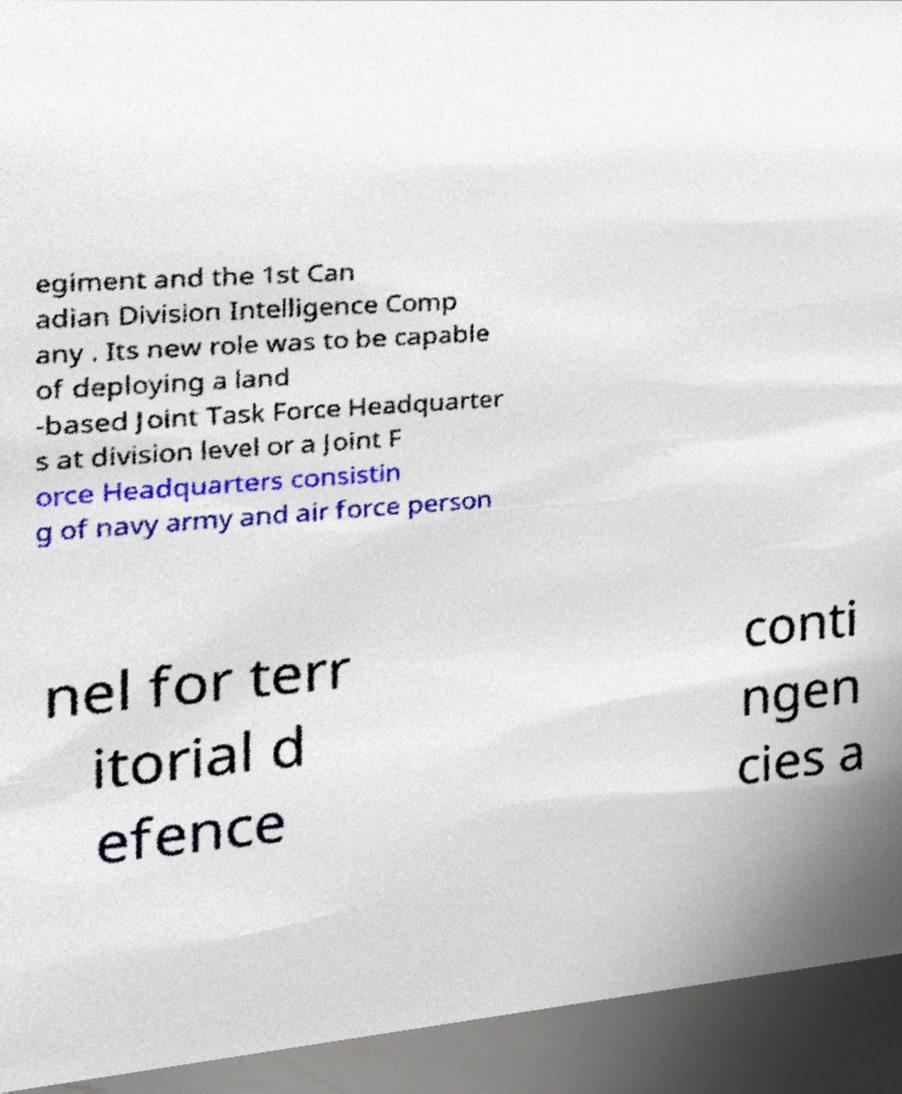I need the written content from this picture converted into text. Can you do that? egiment and the 1st Can adian Division Intelligence Comp any . Its new role was to be capable of deploying a land -based Joint Task Force Headquarter s at division level or a Joint F orce Headquarters consistin g of navy army and air force person nel for terr itorial d efence conti ngen cies a 